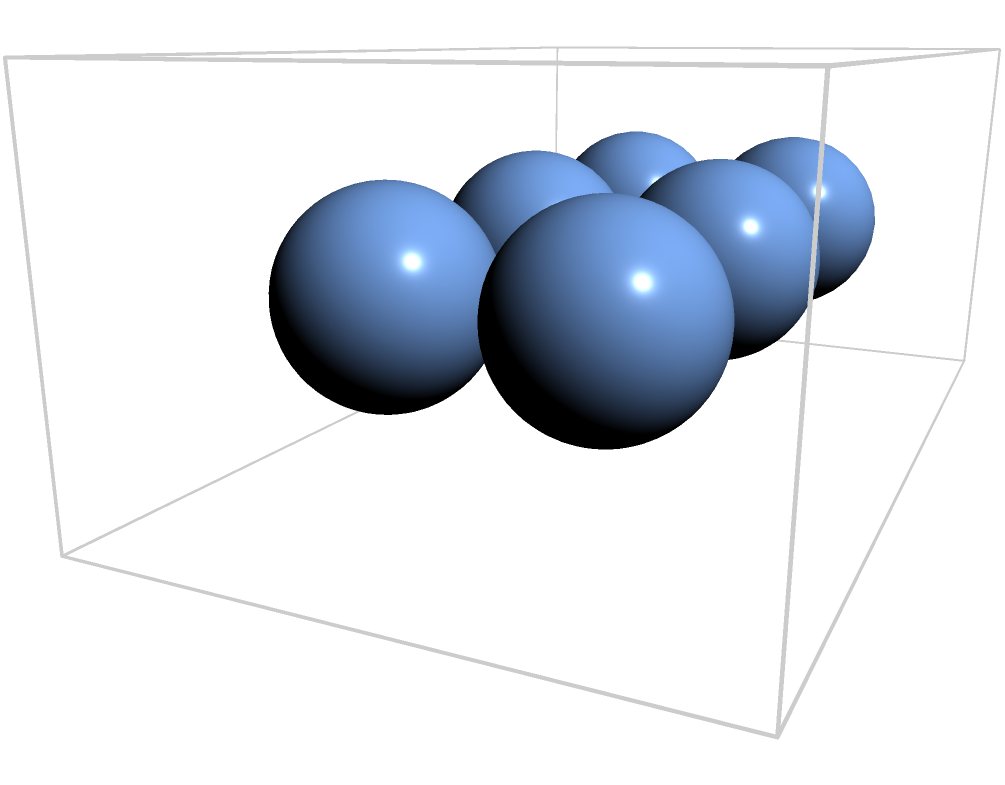For our upcoming youth group charity event, we're planning to fill donation boxes with spherical ornaments symbolizing unity and faith. If each rectangular donation box measures 10 inches long, 6 inches wide, and 4 inches high, and each spherical ornament has a diameter of 2 inches, how many ornaments can we fit in each box? To solve this problem, we'll follow these steps:

1. Calculate the volume of the rectangular box:
   $V_{box} = l \times w \times h = 10 \times 6 \times 4 = 240$ cubic inches

2. Calculate the volume of each spherical ornament:
   $V_{sphere} = \frac{4}{3}\pi r^3 = \frac{4}{3}\pi 1^3 = \frac{4}{3}\pi$ cubic inches

3. Determine the packing efficiency:
   In practice, spheres don't pack perfectly in a rectangular box. The maximum theoretical packing density for equal spheres in a box is approximately 74% (π/(3√2) ≈ 0.74).

4. Calculate the effective volume available for spheres:
   $V_{effective} = 0.74 \times V_{box} = 0.74 \times 240 = 177.6$ cubic inches

5. Calculate the number of ornaments that can fit:
   $N = \frac{V_{effective}}{V_{sphere}} = \frac{177.6}{\frac{4}{3}\pi} \approx 42.3$

6. Round down to the nearest whole number, as we can't have partial ornaments.

Therefore, we can fit 42 ornaments in each donation box.
Answer: 42 ornaments 